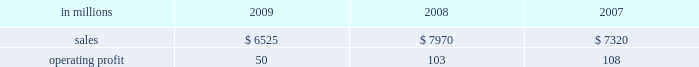Higher in the first half of the year , but declined dur- ing the second half of the year reflecting the pass- through to customers of lower resin input costs .
However , average margins benefitted from a more favorable mix of products sold .
Raw material costs were lower , primarily for resins .
Freight costs were also favorable , while operating costs increased .
Shorewood sales volumes in 2009 declined from 2008 levels reflecting weaker demand in the home entertainment segment and a decrease in tobacco segment orders as customers have shifted pro- duction outside of the united states , partially offset by higher shipments in the consumer products segment .
Average sales margins improved reflecting a more favorable mix of products sold .
Raw material costs were higher , but were partially offset by lower freight costs .
Operating costs were favorable , reflect- ing benefits from business reorganization and cost reduction actions taken in 2008 and 2009 .
Charges to restructure operations totaled $ 7 million in 2009 and $ 30 million in 2008 .
Entering 2010 , coated paperboard sales volumes are expected to increase , while average sales price real- izations should be comparable to 2009 fourth-quarter levels .
Raw material costs are expected to be sig- nificantly higher for wood , energy and chemicals , but planned maintenance downtime costs will decrease .
Foodservice sales volumes are expected to remain about flat , but average sales price realizations should improve slightly .
Input costs for resins should be higher , but will be partially offset by lower costs for bleached board .
Shorewood sales volumes are expected to decline reflecting seasonal decreases in home entertainment segment shipments .
Operating costs are expected to be favorable reflecting the benefits of business reorganization efforts .
European consumer packaging net sales in 2009 were $ 315 million compared with $ 300 million in 2008 and $ 280 million in 2007 .
Operating earnings in 2009 of $ 66 million increased from $ 22 million in 2008 and $ 30 million in 2007 .
Sales volumes in 2009 were higher than in 2008 reflecting increased ship- ments to export markets .
Average sales margins declined due to increased shipments to lower- margin export markets and lower average sales prices in western europe .
Entering 2010 , sales volumes for the first quarter are expected to remain strong .
Average margins should improve reflecting increased sales price realizations and a more favorable geographic mix of products sold .
Input costs are expected to be higher due to increased wood prices in poland and annual energy tariff increases in russia .
Asian consumer packaging net sales were $ 545 million in 2009 compared with $ 390 million in 2008 and $ 330 million in 2007 .
Operating earnings in 2009 were $ 24 million compared with a loss of $ 13 million in 2008 and earnings of $ 12 million in 2007 .
The improved operating earnings in 2009 reflect increased sales volumes , higher average sales mar- gins and lower input costs , primarily for chemicals .
The loss in 2008 was primarily due to a $ 12 million charge to revalue pulp inventories at our shandong international paper and sun coated paperboard co. , ltd .
Joint venture and start-up costs associated with the joint venture 2019s new folding box board paper machine .
Distribution xpedx , our distribution business , markets a diverse array of products and supply chain services to cus- tomers in many business segments .
Customer demand is generally sensitive to changes in general economic conditions , although the commercial printing segment is also dependent on consumer advertising and promotional spending .
Distribution 2019s margins are relatively stable across an economic cycle .
Providing customers with the best choice and value in both products and supply chain services is a key competitive factor .
Additionally , efficient customer service , cost-effective logistics and focused working capital management are key factors in this segment 2019s profitability .
Distribution in millions 2009 2008 2007 .
Distribution 2019s 2009 annual sales decreased 18% ( 18 % ) from 2008 and 11% ( 11 % ) from 2007 while operating profits in 2009 decreased 51% ( 51 % ) compared with 2008 and 54% ( 54 % ) compared with 2007 .
Annual sales of printing papers and graphic arts supplies and equipment totaled $ 4.1 billion in 2009 compared with $ 5.2 billion in 2008 and $ 4.7 billion in 2007 , reflecting weak economic conditions in 2009 .
Trade margins as a percent of sales for printing papers increased from 2008 but decreased from 2007 due to a higher mix of lower margin direct ship- ments from manufacturers .
Revenue from packaging products was $ 1.3 billion in 2009 compared with $ 1.7 billion in 2008 and $ 1.5 billion in 2007 .
Trade margins as a percent of sales for packaging products were higher than in the past two years reflecting an improved product and service mix .
Facility supplies annual revenue was $ 1.1 billion in 2009 , essentially .
What was the percentage decrease in annual sales of printing papers and graphic arts supplies and equipment from 2008 to 2009? 
Computations: ((5.2 - 4.1) / 5.2)
Answer: 0.21154. 